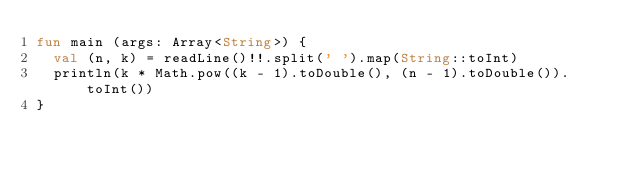Convert code to text. <code><loc_0><loc_0><loc_500><loc_500><_Kotlin_>fun main (args: Array<String>) {
  val (n, k) = readLine()!!.split(' ').map(String::toInt)
  println(k * Math.pow((k - 1).toDouble(), (n - 1).toDouble()).toInt())
}</code> 